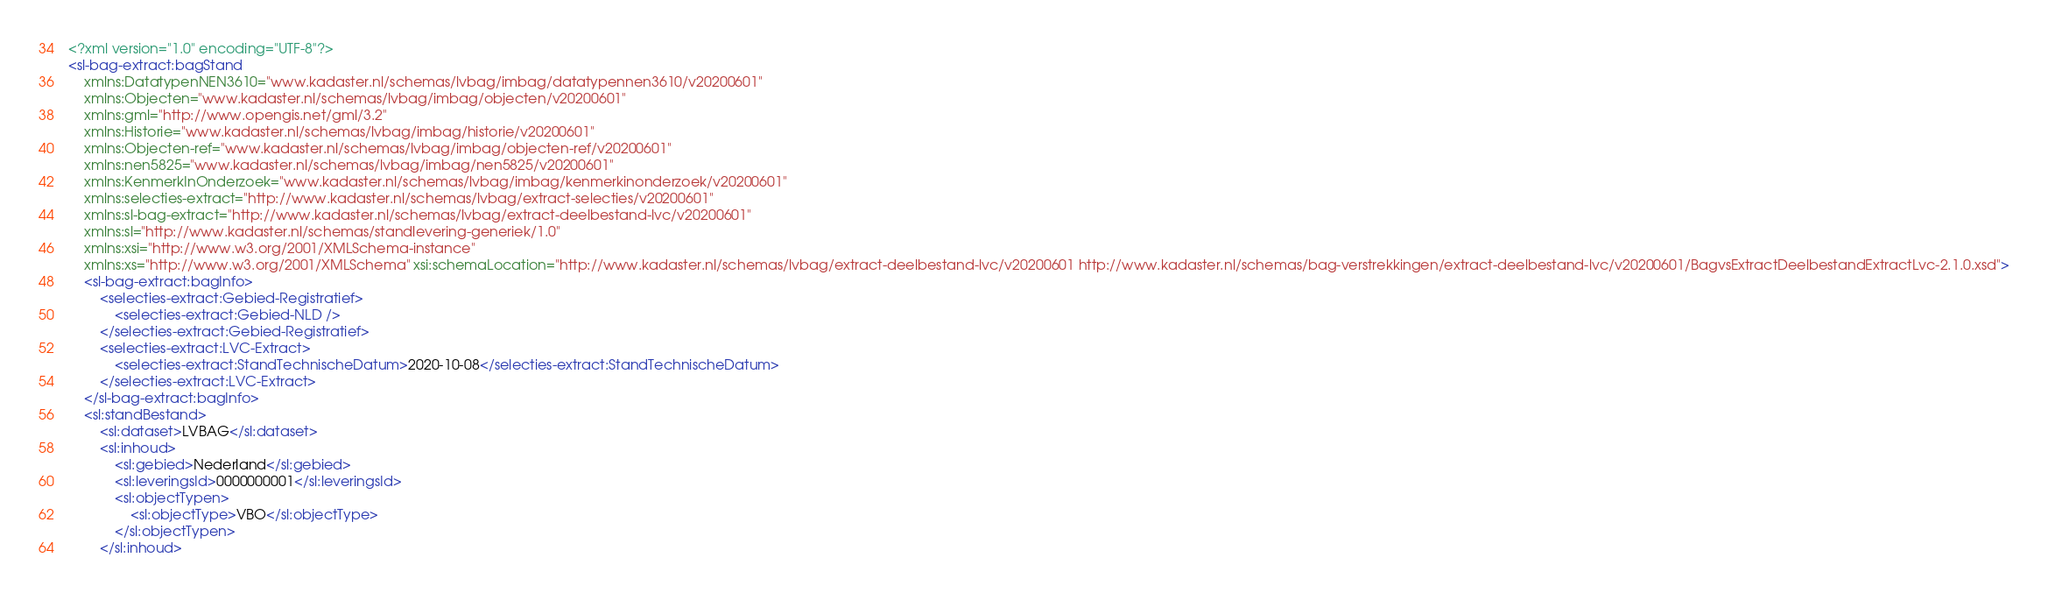<code> <loc_0><loc_0><loc_500><loc_500><_XML_><?xml version="1.0" encoding="UTF-8"?>
<sl-bag-extract:bagStand
    xmlns:DatatypenNEN3610="www.kadaster.nl/schemas/lvbag/imbag/datatypennen3610/v20200601"
    xmlns:Objecten="www.kadaster.nl/schemas/lvbag/imbag/objecten/v20200601"
    xmlns:gml="http://www.opengis.net/gml/3.2"
    xmlns:Historie="www.kadaster.nl/schemas/lvbag/imbag/historie/v20200601"
    xmlns:Objecten-ref="www.kadaster.nl/schemas/lvbag/imbag/objecten-ref/v20200601"
    xmlns:nen5825="www.kadaster.nl/schemas/lvbag/imbag/nen5825/v20200601"
    xmlns:KenmerkInOnderzoek="www.kadaster.nl/schemas/lvbag/imbag/kenmerkinonderzoek/v20200601"
    xmlns:selecties-extract="http://www.kadaster.nl/schemas/lvbag/extract-selecties/v20200601"
    xmlns:sl-bag-extract="http://www.kadaster.nl/schemas/lvbag/extract-deelbestand-lvc/v20200601"
    xmlns:sl="http://www.kadaster.nl/schemas/standlevering-generiek/1.0"
    xmlns:xsi="http://www.w3.org/2001/XMLSchema-instance"
    xmlns:xs="http://www.w3.org/2001/XMLSchema" xsi:schemaLocation="http://www.kadaster.nl/schemas/lvbag/extract-deelbestand-lvc/v20200601 http://www.kadaster.nl/schemas/bag-verstrekkingen/extract-deelbestand-lvc/v20200601/BagvsExtractDeelbestandExtractLvc-2.1.0.xsd">
    <sl-bag-extract:bagInfo>
        <selecties-extract:Gebied-Registratief>
            <selecties-extract:Gebied-NLD />
        </selecties-extract:Gebied-Registratief>
        <selecties-extract:LVC-Extract>
            <selecties-extract:StandTechnischeDatum>2020-10-08</selecties-extract:StandTechnischeDatum>
        </selecties-extract:LVC-Extract>
    </sl-bag-extract:bagInfo>
    <sl:standBestand>
        <sl:dataset>LVBAG</sl:dataset>
        <sl:inhoud>
            <sl:gebied>Nederland</sl:gebied>
            <sl:leveringsId>0000000001</sl:leveringsId>
            <sl:objectTypen>
                <sl:objectType>VBO</sl:objectType>
            </sl:objectTypen>
        </sl:inhoud></code> 